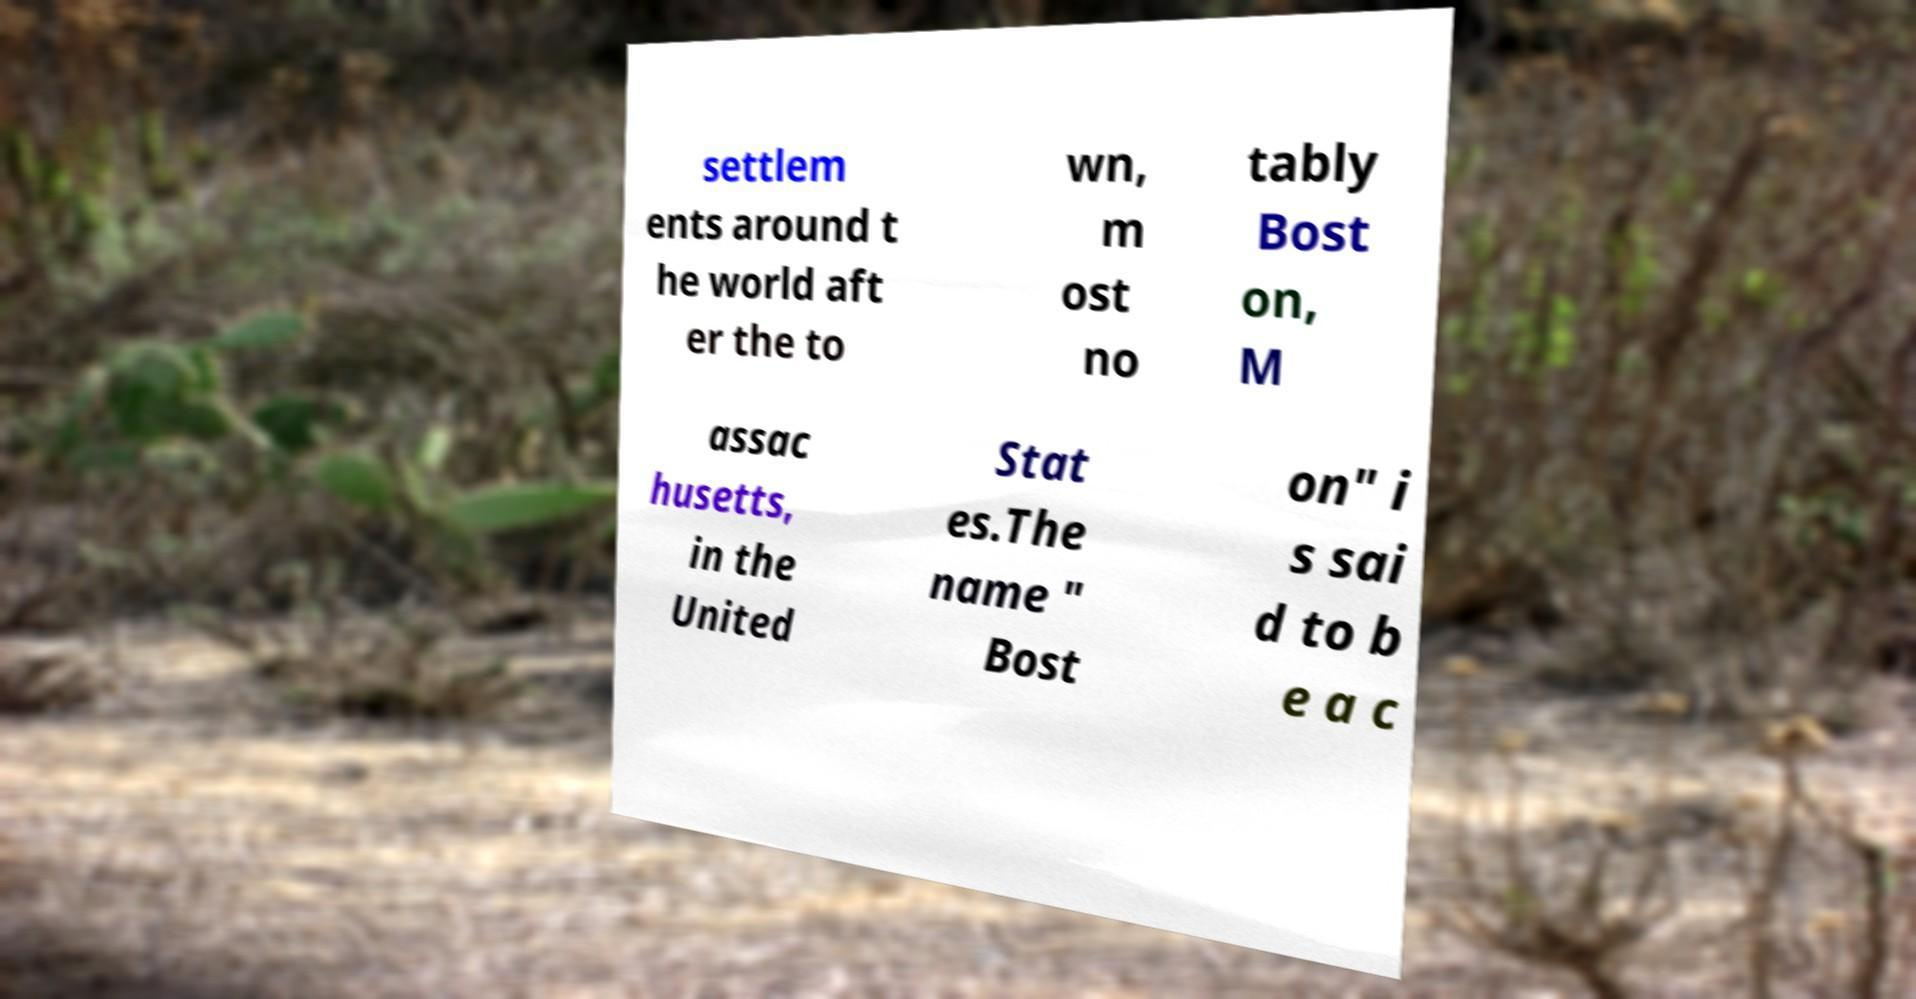There's text embedded in this image that I need extracted. Can you transcribe it verbatim? settlem ents around t he world aft er the to wn, m ost no tably Bost on, M assac husetts, in the United Stat es.The name " Bost on" i s sai d to b e a c 